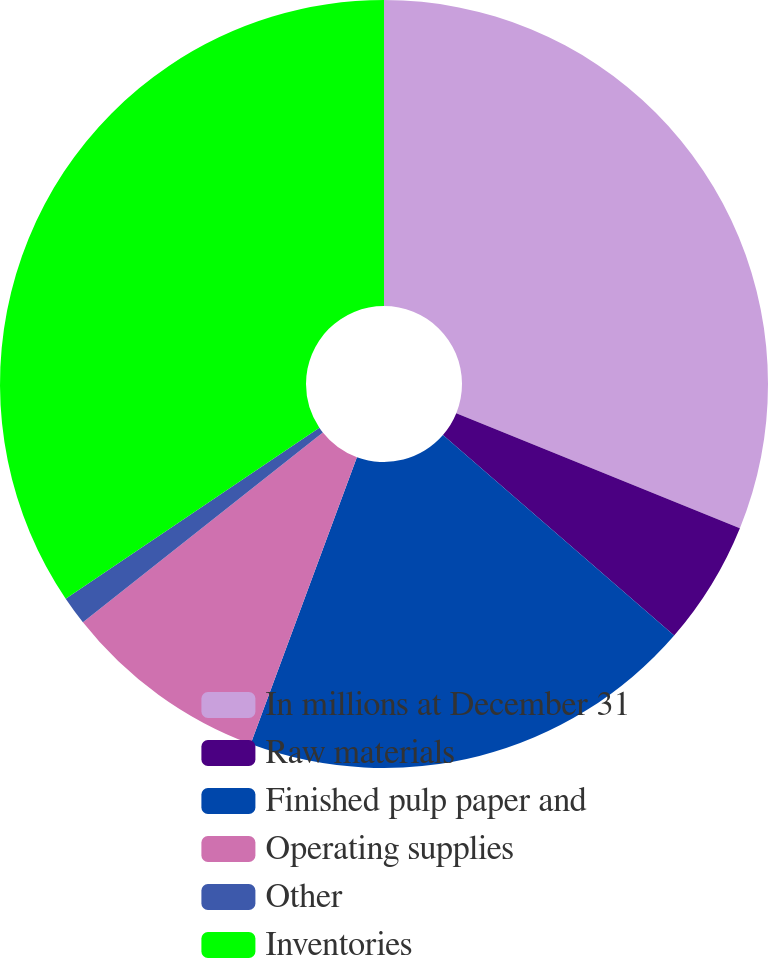Convert chart to OTSL. <chart><loc_0><loc_0><loc_500><loc_500><pie_chart><fcel>In millions at December 31<fcel>Raw materials<fcel>Finished pulp paper and<fcel>Operating supplies<fcel>Other<fcel>Inventories<nl><fcel>31.13%<fcel>5.24%<fcel>19.28%<fcel>8.7%<fcel>1.21%<fcel>34.45%<nl></chart> 